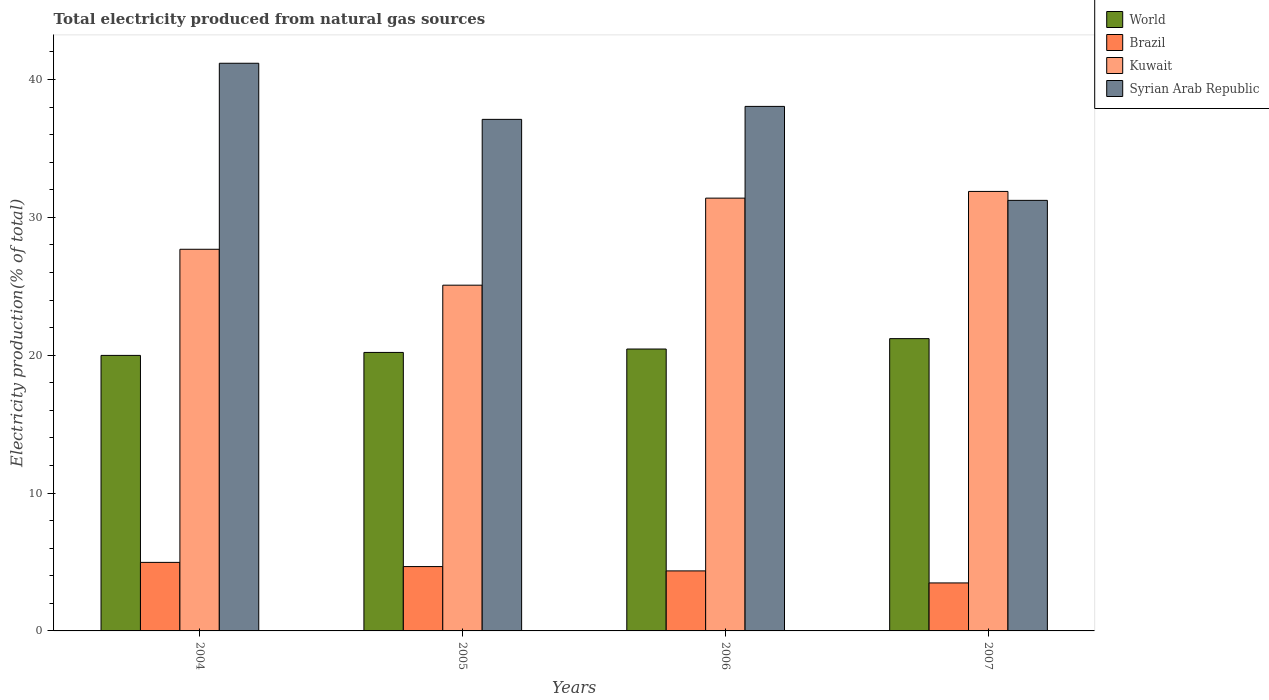How many different coloured bars are there?
Provide a short and direct response. 4. Are the number of bars on each tick of the X-axis equal?
Your response must be concise. Yes. How many bars are there on the 3rd tick from the left?
Keep it short and to the point. 4. How many bars are there on the 4th tick from the right?
Keep it short and to the point. 4. What is the total electricity produced in Kuwait in 2004?
Provide a short and direct response. 27.68. Across all years, what is the maximum total electricity produced in Kuwait?
Make the answer very short. 31.88. Across all years, what is the minimum total electricity produced in Kuwait?
Offer a very short reply. 25.08. In which year was the total electricity produced in World maximum?
Your answer should be compact. 2007. In which year was the total electricity produced in World minimum?
Give a very brief answer. 2004. What is the total total electricity produced in Syrian Arab Republic in the graph?
Your answer should be compact. 147.56. What is the difference between the total electricity produced in Syrian Arab Republic in 2005 and that in 2006?
Give a very brief answer. -0.94. What is the difference between the total electricity produced in Kuwait in 2007 and the total electricity produced in World in 2004?
Provide a short and direct response. 11.89. What is the average total electricity produced in Kuwait per year?
Your response must be concise. 29.01. In the year 2005, what is the difference between the total electricity produced in World and total electricity produced in Brazil?
Your answer should be compact. 15.53. What is the ratio of the total electricity produced in Brazil in 2004 to that in 2005?
Your response must be concise. 1.07. Is the total electricity produced in Kuwait in 2005 less than that in 2006?
Your response must be concise. Yes. Is the difference between the total electricity produced in World in 2004 and 2005 greater than the difference between the total electricity produced in Brazil in 2004 and 2005?
Ensure brevity in your answer.  No. What is the difference between the highest and the second highest total electricity produced in Syrian Arab Republic?
Make the answer very short. 3.13. What is the difference between the highest and the lowest total electricity produced in Kuwait?
Keep it short and to the point. 6.8. In how many years, is the total electricity produced in World greater than the average total electricity produced in World taken over all years?
Provide a succinct answer. 1. Is it the case that in every year, the sum of the total electricity produced in Kuwait and total electricity produced in Brazil is greater than the sum of total electricity produced in World and total electricity produced in Syrian Arab Republic?
Provide a short and direct response. Yes. What does the 3rd bar from the left in 2005 represents?
Make the answer very short. Kuwait. Is it the case that in every year, the sum of the total electricity produced in World and total electricity produced in Brazil is greater than the total electricity produced in Syrian Arab Republic?
Offer a very short reply. No. How many years are there in the graph?
Keep it short and to the point. 4. Are the values on the major ticks of Y-axis written in scientific E-notation?
Offer a very short reply. No. How are the legend labels stacked?
Offer a terse response. Vertical. What is the title of the graph?
Give a very brief answer. Total electricity produced from natural gas sources. Does "North America" appear as one of the legend labels in the graph?
Keep it short and to the point. No. What is the Electricity production(% of total) of World in 2004?
Your response must be concise. 19.99. What is the Electricity production(% of total) of Brazil in 2004?
Provide a succinct answer. 4.97. What is the Electricity production(% of total) in Kuwait in 2004?
Provide a short and direct response. 27.68. What is the Electricity production(% of total) of Syrian Arab Republic in 2004?
Your answer should be compact. 41.18. What is the Electricity production(% of total) of World in 2005?
Your answer should be very brief. 20.2. What is the Electricity production(% of total) of Brazil in 2005?
Offer a very short reply. 4.67. What is the Electricity production(% of total) in Kuwait in 2005?
Offer a very short reply. 25.08. What is the Electricity production(% of total) of Syrian Arab Republic in 2005?
Your answer should be compact. 37.11. What is the Electricity production(% of total) of World in 2006?
Provide a succinct answer. 20.45. What is the Electricity production(% of total) in Brazil in 2006?
Offer a very short reply. 4.35. What is the Electricity production(% of total) of Kuwait in 2006?
Provide a succinct answer. 31.39. What is the Electricity production(% of total) of Syrian Arab Republic in 2006?
Offer a very short reply. 38.05. What is the Electricity production(% of total) in World in 2007?
Provide a succinct answer. 21.2. What is the Electricity production(% of total) in Brazil in 2007?
Offer a very short reply. 3.48. What is the Electricity production(% of total) of Kuwait in 2007?
Your answer should be very brief. 31.88. What is the Electricity production(% of total) of Syrian Arab Republic in 2007?
Make the answer very short. 31.23. Across all years, what is the maximum Electricity production(% of total) in World?
Your answer should be compact. 21.2. Across all years, what is the maximum Electricity production(% of total) of Brazil?
Offer a very short reply. 4.97. Across all years, what is the maximum Electricity production(% of total) of Kuwait?
Give a very brief answer. 31.88. Across all years, what is the maximum Electricity production(% of total) in Syrian Arab Republic?
Your answer should be compact. 41.18. Across all years, what is the minimum Electricity production(% of total) in World?
Provide a succinct answer. 19.99. Across all years, what is the minimum Electricity production(% of total) in Brazil?
Keep it short and to the point. 3.48. Across all years, what is the minimum Electricity production(% of total) in Kuwait?
Your answer should be compact. 25.08. Across all years, what is the minimum Electricity production(% of total) of Syrian Arab Republic?
Offer a very short reply. 31.23. What is the total Electricity production(% of total) of World in the graph?
Provide a short and direct response. 81.83. What is the total Electricity production(% of total) of Brazil in the graph?
Your response must be concise. 17.47. What is the total Electricity production(% of total) of Kuwait in the graph?
Your answer should be compact. 116.03. What is the total Electricity production(% of total) of Syrian Arab Republic in the graph?
Provide a short and direct response. 147.56. What is the difference between the Electricity production(% of total) in World in 2004 and that in 2005?
Give a very brief answer. -0.21. What is the difference between the Electricity production(% of total) of Brazil in 2004 and that in 2005?
Offer a very short reply. 0.3. What is the difference between the Electricity production(% of total) of Kuwait in 2004 and that in 2005?
Ensure brevity in your answer.  2.6. What is the difference between the Electricity production(% of total) in Syrian Arab Republic in 2004 and that in 2005?
Your answer should be compact. 4.07. What is the difference between the Electricity production(% of total) of World in 2004 and that in 2006?
Your answer should be compact. -0.46. What is the difference between the Electricity production(% of total) in Brazil in 2004 and that in 2006?
Offer a terse response. 0.62. What is the difference between the Electricity production(% of total) of Kuwait in 2004 and that in 2006?
Provide a short and direct response. -3.71. What is the difference between the Electricity production(% of total) in Syrian Arab Republic in 2004 and that in 2006?
Offer a very short reply. 3.13. What is the difference between the Electricity production(% of total) in World in 2004 and that in 2007?
Provide a succinct answer. -1.22. What is the difference between the Electricity production(% of total) in Brazil in 2004 and that in 2007?
Provide a short and direct response. 1.49. What is the difference between the Electricity production(% of total) of Kuwait in 2004 and that in 2007?
Ensure brevity in your answer.  -4.2. What is the difference between the Electricity production(% of total) in Syrian Arab Republic in 2004 and that in 2007?
Your answer should be compact. 9.95. What is the difference between the Electricity production(% of total) of World in 2005 and that in 2006?
Offer a very short reply. -0.25. What is the difference between the Electricity production(% of total) in Brazil in 2005 and that in 2006?
Your answer should be very brief. 0.31. What is the difference between the Electricity production(% of total) in Kuwait in 2005 and that in 2006?
Ensure brevity in your answer.  -6.31. What is the difference between the Electricity production(% of total) of Syrian Arab Republic in 2005 and that in 2006?
Your answer should be compact. -0.94. What is the difference between the Electricity production(% of total) of World in 2005 and that in 2007?
Ensure brevity in your answer.  -1. What is the difference between the Electricity production(% of total) in Brazil in 2005 and that in 2007?
Offer a very short reply. 1.19. What is the difference between the Electricity production(% of total) in Kuwait in 2005 and that in 2007?
Your answer should be very brief. -6.8. What is the difference between the Electricity production(% of total) of Syrian Arab Republic in 2005 and that in 2007?
Give a very brief answer. 5.88. What is the difference between the Electricity production(% of total) in World in 2006 and that in 2007?
Provide a succinct answer. -0.75. What is the difference between the Electricity production(% of total) in Brazil in 2006 and that in 2007?
Offer a very short reply. 0.87. What is the difference between the Electricity production(% of total) of Kuwait in 2006 and that in 2007?
Offer a very short reply. -0.49. What is the difference between the Electricity production(% of total) of Syrian Arab Republic in 2006 and that in 2007?
Offer a terse response. 6.82. What is the difference between the Electricity production(% of total) of World in 2004 and the Electricity production(% of total) of Brazil in 2005?
Your answer should be compact. 15.32. What is the difference between the Electricity production(% of total) of World in 2004 and the Electricity production(% of total) of Kuwait in 2005?
Make the answer very short. -5.09. What is the difference between the Electricity production(% of total) of World in 2004 and the Electricity production(% of total) of Syrian Arab Republic in 2005?
Offer a terse response. -17.12. What is the difference between the Electricity production(% of total) in Brazil in 2004 and the Electricity production(% of total) in Kuwait in 2005?
Your response must be concise. -20.11. What is the difference between the Electricity production(% of total) of Brazil in 2004 and the Electricity production(% of total) of Syrian Arab Republic in 2005?
Offer a very short reply. -32.13. What is the difference between the Electricity production(% of total) of Kuwait in 2004 and the Electricity production(% of total) of Syrian Arab Republic in 2005?
Your answer should be compact. -9.42. What is the difference between the Electricity production(% of total) in World in 2004 and the Electricity production(% of total) in Brazil in 2006?
Make the answer very short. 15.63. What is the difference between the Electricity production(% of total) of World in 2004 and the Electricity production(% of total) of Kuwait in 2006?
Provide a short and direct response. -11.41. What is the difference between the Electricity production(% of total) of World in 2004 and the Electricity production(% of total) of Syrian Arab Republic in 2006?
Your response must be concise. -18.06. What is the difference between the Electricity production(% of total) in Brazil in 2004 and the Electricity production(% of total) in Kuwait in 2006?
Your response must be concise. -26.42. What is the difference between the Electricity production(% of total) of Brazil in 2004 and the Electricity production(% of total) of Syrian Arab Republic in 2006?
Your response must be concise. -33.07. What is the difference between the Electricity production(% of total) of Kuwait in 2004 and the Electricity production(% of total) of Syrian Arab Republic in 2006?
Your answer should be compact. -10.36. What is the difference between the Electricity production(% of total) of World in 2004 and the Electricity production(% of total) of Brazil in 2007?
Your answer should be very brief. 16.5. What is the difference between the Electricity production(% of total) in World in 2004 and the Electricity production(% of total) in Kuwait in 2007?
Your answer should be very brief. -11.89. What is the difference between the Electricity production(% of total) in World in 2004 and the Electricity production(% of total) in Syrian Arab Republic in 2007?
Ensure brevity in your answer.  -11.24. What is the difference between the Electricity production(% of total) in Brazil in 2004 and the Electricity production(% of total) in Kuwait in 2007?
Give a very brief answer. -26.91. What is the difference between the Electricity production(% of total) in Brazil in 2004 and the Electricity production(% of total) in Syrian Arab Republic in 2007?
Give a very brief answer. -26.26. What is the difference between the Electricity production(% of total) in Kuwait in 2004 and the Electricity production(% of total) in Syrian Arab Republic in 2007?
Keep it short and to the point. -3.55. What is the difference between the Electricity production(% of total) of World in 2005 and the Electricity production(% of total) of Brazil in 2006?
Your response must be concise. 15.85. What is the difference between the Electricity production(% of total) of World in 2005 and the Electricity production(% of total) of Kuwait in 2006?
Your answer should be compact. -11.19. What is the difference between the Electricity production(% of total) of World in 2005 and the Electricity production(% of total) of Syrian Arab Republic in 2006?
Offer a terse response. -17.85. What is the difference between the Electricity production(% of total) of Brazil in 2005 and the Electricity production(% of total) of Kuwait in 2006?
Your answer should be compact. -26.72. What is the difference between the Electricity production(% of total) of Brazil in 2005 and the Electricity production(% of total) of Syrian Arab Republic in 2006?
Provide a short and direct response. -33.38. What is the difference between the Electricity production(% of total) of Kuwait in 2005 and the Electricity production(% of total) of Syrian Arab Republic in 2006?
Keep it short and to the point. -12.97. What is the difference between the Electricity production(% of total) in World in 2005 and the Electricity production(% of total) in Brazil in 2007?
Ensure brevity in your answer.  16.72. What is the difference between the Electricity production(% of total) in World in 2005 and the Electricity production(% of total) in Kuwait in 2007?
Provide a short and direct response. -11.68. What is the difference between the Electricity production(% of total) in World in 2005 and the Electricity production(% of total) in Syrian Arab Republic in 2007?
Ensure brevity in your answer.  -11.03. What is the difference between the Electricity production(% of total) of Brazil in 2005 and the Electricity production(% of total) of Kuwait in 2007?
Keep it short and to the point. -27.21. What is the difference between the Electricity production(% of total) of Brazil in 2005 and the Electricity production(% of total) of Syrian Arab Republic in 2007?
Ensure brevity in your answer.  -26.56. What is the difference between the Electricity production(% of total) in Kuwait in 2005 and the Electricity production(% of total) in Syrian Arab Republic in 2007?
Provide a short and direct response. -6.15. What is the difference between the Electricity production(% of total) in World in 2006 and the Electricity production(% of total) in Brazil in 2007?
Ensure brevity in your answer.  16.97. What is the difference between the Electricity production(% of total) in World in 2006 and the Electricity production(% of total) in Kuwait in 2007?
Ensure brevity in your answer.  -11.43. What is the difference between the Electricity production(% of total) in World in 2006 and the Electricity production(% of total) in Syrian Arab Republic in 2007?
Your response must be concise. -10.78. What is the difference between the Electricity production(% of total) of Brazil in 2006 and the Electricity production(% of total) of Kuwait in 2007?
Ensure brevity in your answer.  -27.52. What is the difference between the Electricity production(% of total) in Brazil in 2006 and the Electricity production(% of total) in Syrian Arab Republic in 2007?
Provide a succinct answer. -26.88. What is the difference between the Electricity production(% of total) of Kuwait in 2006 and the Electricity production(% of total) of Syrian Arab Republic in 2007?
Offer a very short reply. 0.16. What is the average Electricity production(% of total) in World per year?
Keep it short and to the point. 20.46. What is the average Electricity production(% of total) of Brazil per year?
Your response must be concise. 4.37. What is the average Electricity production(% of total) in Kuwait per year?
Offer a terse response. 29.01. What is the average Electricity production(% of total) of Syrian Arab Republic per year?
Your answer should be compact. 36.89. In the year 2004, what is the difference between the Electricity production(% of total) of World and Electricity production(% of total) of Brazil?
Offer a very short reply. 15.01. In the year 2004, what is the difference between the Electricity production(% of total) in World and Electricity production(% of total) in Kuwait?
Your answer should be very brief. -7.7. In the year 2004, what is the difference between the Electricity production(% of total) of World and Electricity production(% of total) of Syrian Arab Republic?
Give a very brief answer. -21.19. In the year 2004, what is the difference between the Electricity production(% of total) in Brazil and Electricity production(% of total) in Kuwait?
Provide a succinct answer. -22.71. In the year 2004, what is the difference between the Electricity production(% of total) in Brazil and Electricity production(% of total) in Syrian Arab Republic?
Your answer should be compact. -36.2. In the year 2004, what is the difference between the Electricity production(% of total) of Kuwait and Electricity production(% of total) of Syrian Arab Republic?
Offer a very short reply. -13.49. In the year 2005, what is the difference between the Electricity production(% of total) in World and Electricity production(% of total) in Brazil?
Your answer should be compact. 15.53. In the year 2005, what is the difference between the Electricity production(% of total) of World and Electricity production(% of total) of Kuwait?
Provide a short and direct response. -4.88. In the year 2005, what is the difference between the Electricity production(% of total) in World and Electricity production(% of total) in Syrian Arab Republic?
Your answer should be very brief. -16.91. In the year 2005, what is the difference between the Electricity production(% of total) of Brazil and Electricity production(% of total) of Kuwait?
Your answer should be very brief. -20.41. In the year 2005, what is the difference between the Electricity production(% of total) in Brazil and Electricity production(% of total) in Syrian Arab Republic?
Give a very brief answer. -32.44. In the year 2005, what is the difference between the Electricity production(% of total) in Kuwait and Electricity production(% of total) in Syrian Arab Republic?
Make the answer very short. -12.03. In the year 2006, what is the difference between the Electricity production(% of total) of World and Electricity production(% of total) of Brazil?
Your answer should be compact. 16.09. In the year 2006, what is the difference between the Electricity production(% of total) of World and Electricity production(% of total) of Kuwait?
Provide a succinct answer. -10.94. In the year 2006, what is the difference between the Electricity production(% of total) in World and Electricity production(% of total) in Syrian Arab Republic?
Make the answer very short. -17.6. In the year 2006, what is the difference between the Electricity production(% of total) in Brazil and Electricity production(% of total) in Kuwait?
Offer a very short reply. -27.04. In the year 2006, what is the difference between the Electricity production(% of total) of Brazil and Electricity production(% of total) of Syrian Arab Republic?
Keep it short and to the point. -33.69. In the year 2006, what is the difference between the Electricity production(% of total) in Kuwait and Electricity production(% of total) in Syrian Arab Republic?
Make the answer very short. -6.65. In the year 2007, what is the difference between the Electricity production(% of total) of World and Electricity production(% of total) of Brazil?
Offer a terse response. 17.72. In the year 2007, what is the difference between the Electricity production(% of total) in World and Electricity production(% of total) in Kuwait?
Provide a short and direct response. -10.68. In the year 2007, what is the difference between the Electricity production(% of total) of World and Electricity production(% of total) of Syrian Arab Republic?
Your response must be concise. -10.03. In the year 2007, what is the difference between the Electricity production(% of total) in Brazil and Electricity production(% of total) in Kuwait?
Keep it short and to the point. -28.4. In the year 2007, what is the difference between the Electricity production(% of total) of Brazil and Electricity production(% of total) of Syrian Arab Republic?
Offer a terse response. -27.75. In the year 2007, what is the difference between the Electricity production(% of total) of Kuwait and Electricity production(% of total) of Syrian Arab Republic?
Give a very brief answer. 0.65. What is the ratio of the Electricity production(% of total) in Brazil in 2004 to that in 2005?
Your response must be concise. 1.07. What is the ratio of the Electricity production(% of total) of Kuwait in 2004 to that in 2005?
Offer a terse response. 1.1. What is the ratio of the Electricity production(% of total) of Syrian Arab Republic in 2004 to that in 2005?
Provide a short and direct response. 1.11. What is the ratio of the Electricity production(% of total) in World in 2004 to that in 2006?
Your answer should be very brief. 0.98. What is the ratio of the Electricity production(% of total) of Brazil in 2004 to that in 2006?
Provide a succinct answer. 1.14. What is the ratio of the Electricity production(% of total) in Kuwait in 2004 to that in 2006?
Your answer should be very brief. 0.88. What is the ratio of the Electricity production(% of total) in Syrian Arab Republic in 2004 to that in 2006?
Offer a terse response. 1.08. What is the ratio of the Electricity production(% of total) in World in 2004 to that in 2007?
Keep it short and to the point. 0.94. What is the ratio of the Electricity production(% of total) of Brazil in 2004 to that in 2007?
Keep it short and to the point. 1.43. What is the ratio of the Electricity production(% of total) in Kuwait in 2004 to that in 2007?
Offer a very short reply. 0.87. What is the ratio of the Electricity production(% of total) of Syrian Arab Republic in 2004 to that in 2007?
Offer a terse response. 1.32. What is the ratio of the Electricity production(% of total) in World in 2005 to that in 2006?
Keep it short and to the point. 0.99. What is the ratio of the Electricity production(% of total) of Brazil in 2005 to that in 2006?
Offer a terse response. 1.07. What is the ratio of the Electricity production(% of total) of Kuwait in 2005 to that in 2006?
Provide a short and direct response. 0.8. What is the ratio of the Electricity production(% of total) of Syrian Arab Republic in 2005 to that in 2006?
Your answer should be very brief. 0.98. What is the ratio of the Electricity production(% of total) in World in 2005 to that in 2007?
Make the answer very short. 0.95. What is the ratio of the Electricity production(% of total) in Brazil in 2005 to that in 2007?
Make the answer very short. 1.34. What is the ratio of the Electricity production(% of total) in Kuwait in 2005 to that in 2007?
Make the answer very short. 0.79. What is the ratio of the Electricity production(% of total) of Syrian Arab Republic in 2005 to that in 2007?
Give a very brief answer. 1.19. What is the ratio of the Electricity production(% of total) of World in 2006 to that in 2007?
Your response must be concise. 0.96. What is the ratio of the Electricity production(% of total) of Brazil in 2006 to that in 2007?
Provide a short and direct response. 1.25. What is the ratio of the Electricity production(% of total) of Kuwait in 2006 to that in 2007?
Your response must be concise. 0.98. What is the ratio of the Electricity production(% of total) in Syrian Arab Republic in 2006 to that in 2007?
Ensure brevity in your answer.  1.22. What is the difference between the highest and the second highest Electricity production(% of total) in World?
Your answer should be very brief. 0.75. What is the difference between the highest and the second highest Electricity production(% of total) of Brazil?
Provide a short and direct response. 0.3. What is the difference between the highest and the second highest Electricity production(% of total) of Kuwait?
Your answer should be very brief. 0.49. What is the difference between the highest and the second highest Electricity production(% of total) of Syrian Arab Republic?
Provide a succinct answer. 3.13. What is the difference between the highest and the lowest Electricity production(% of total) in World?
Offer a terse response. 1.22. What is the difference between the highest and the lowest Electricity production(% of total) of Brazil?
Provide a succinct answer. 1.49. What is the difference between the highest and the lowest Electricity production(% of total) in Kuwait?
Ensure brevity in your answer.  6.8. What is the difference between the highest and the lowest Electricity production(% of total) of Syrian Arab Republic?
Keep it short and to the point. 9.95. 